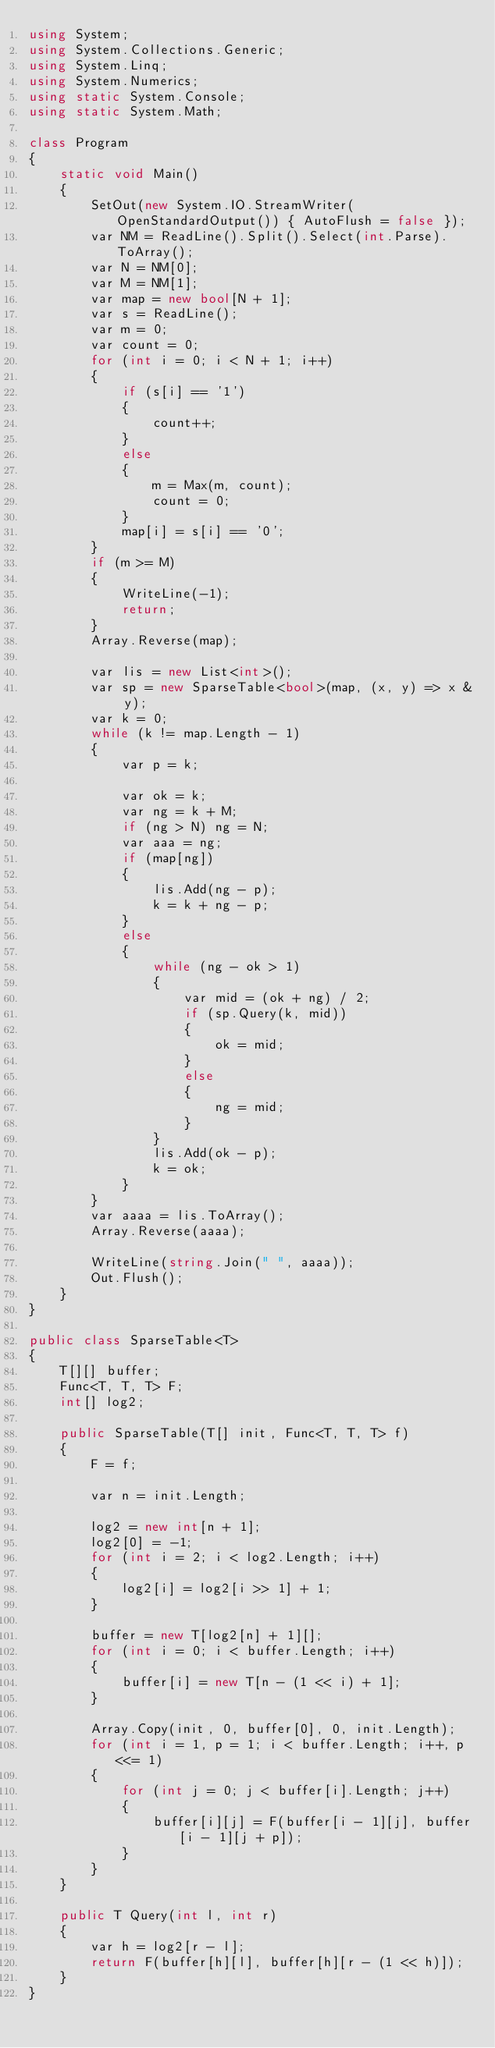Convert code to text. <code><loc_0><loc_0><loc_500><loc_500><_C#_>using System;
using System.Collections.Generic;
using System.Linq;
using System.Numerics;
using static System.Console;
using static System.Math;

class Program
{
    static void Main()
    {
        SetOut(new System.IO.StreamWriter(OpenStandardOutput()) { AutoFlush = false });
        var NM = ReadLine().Split().Select(int.Parse).ToArray();
        var N = NM[0];
        var M = NM[1];
        var map = new bool[N + 1];
        var s = ReadLine();
        var m = 0;
        var count = 0;
        for (int i = 0; i < N + 1; i++)
        {
            if (s[i] == '1')
            {
                count++;
            }
            else
            {
                m = Max(m, count);
                count = 0;
            }
            map[i] = s[i] == '0';
        }
        if (m >= M)
        {
            WriteLine(-1);
            return;
        }
        Array.Reverse(map);

        var lis = new List<int>();
        var sp = new SparseTable<bool>(map, (x, y) => x & y);
        var k = 0;
        while (k != map.Length - 1)
        {
            var p = k;

            var ok = k;
            var ng = k + M;
            if (ng > N) ng = N;
            var aaa = ng;
            if (map[ng])
            {
                lis.Add(ng - p);
                k = k + ng - p;
            }
            else
            {
                while (ng - ok > 1)
                {
                    var mid = (ok + ng) / 2;
                    if (sp.Query(k, mid))
                    {
                        ok = mid;
                    }
                    else
                    {
                        ng = mid;
                    }
                }
                lis.Add(ok - p);
                k = ok;
            }
        }
        var aaaa = lis.ToArray();
        Array.Reverse(aaaa);

        WriteLine(string.Join(" ", aaaa));
        Out.Flush();
    }
}

public class SparseTable<T>
{
    T[][] buffer;
    Func<T, T, T> F;
    int[] log2;

    public SparseTable(T[] init, Func<T, T, T> f)
    {
        F = f;

        var n = init.Length;

        log2 = new int[n + 1];
        log2[0] = -1;
        for (int i = 2; i < log2.Length; i++)
        {
            log2[i] = log2[i >> 1] + 1;
        }

        buffer = new T[log2[n] + 1][];
        for (int i = 0; i < buffer.Length; i++)
        {
            buffer[i] = new T[n - (1 << i) + 1];
        }

        Array.Copy(init, 0, buffer[0], 0, init.Length);
        for (int i = 1, p = 1; i < buffer.Length; i++, p <<= 1)
        {
            for (int j = 0; j < buffer[i].Length; j++)
            {
                buffer[i][j] = F(buffer[i - 1][j], buffer[i - 1][j + p]);
            }
        }
    }

    public T Query(int l, int r)
    {
        var h = log2[r - l];
        return F(buffer[h][l], buffer[h][r - (1 << h)]);
    }
}</code> 